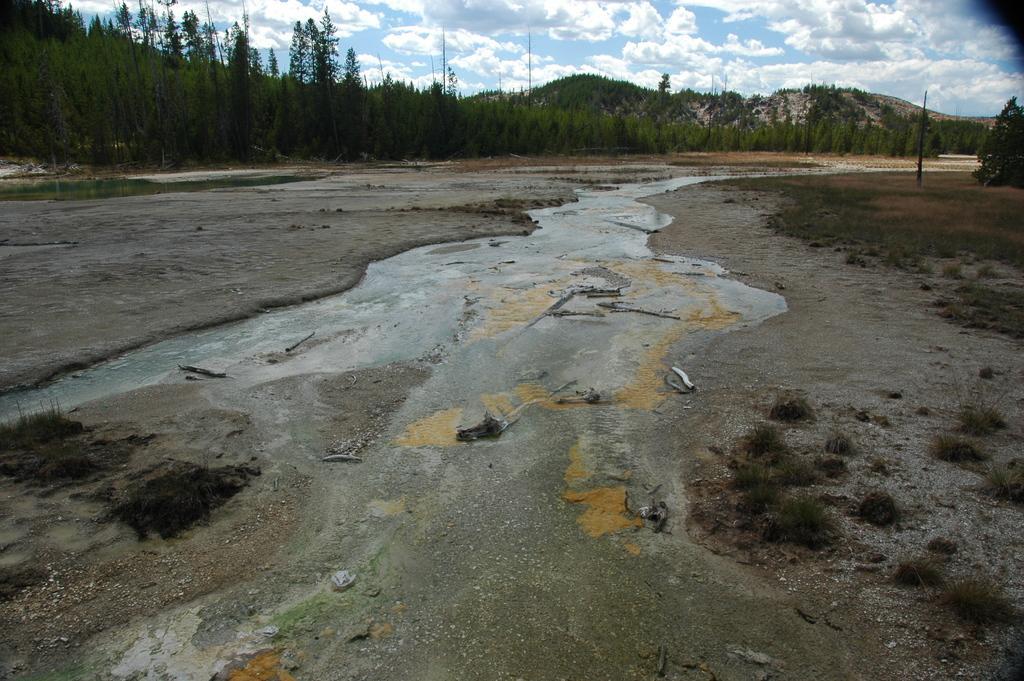In one or two sentences, can you explain what this image depicts? In this image, we can see plants, water and algae. At the top of the image, there are so many trees, pole, hills, plants, water and cloudy sky. 